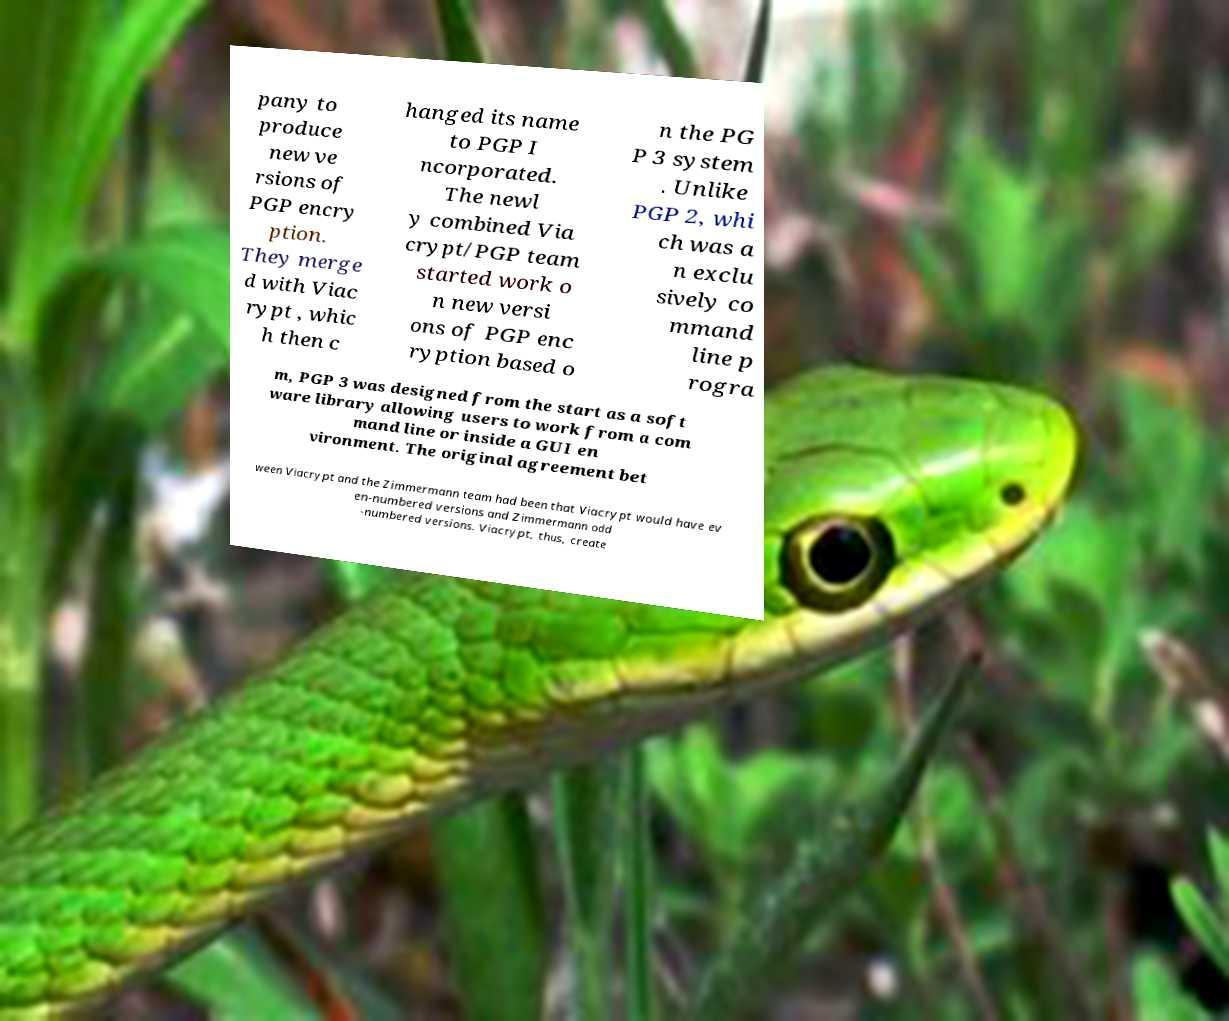What messages or text are displayed in this image? I need them in a readable, typed format. pany to produce new ve rsions of PGP encry ption. They merge d with Viac rypt , whic h then c hanged its name to PGP I ncorporated. The newl y combined Via crypt/PGP team started work o n new versi ons of PGP enc ryption based o n the PG P 3 system . Unlike PGP 2, whi ch was a n exclu sively co mmand line p rogra m, PGP 3 was designed from the start as a soft ware library allowing users to work from a com mand line or inside a GUI en vironment. The original agreement bet ween Viacrypt and the Zimmermann team had been that Viacrypt would have ev en-numbered versions and Zimmermann odd -numbered versions. Viacrypt, thus, create 